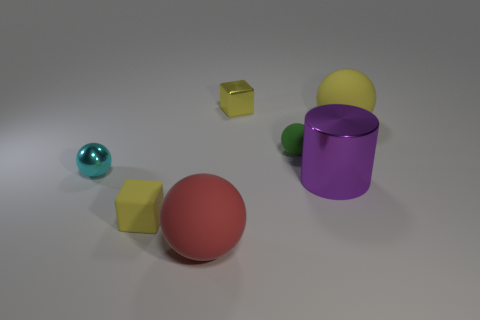Add 1 tiny yellow shiny cubes. How many objects exist? 8 Subtract all cubes. How many objects are left? 5 Subtract 0 purple blocks. How many objects are left? 7 Subtract all large metallic cylinders. Subtract all tiny green things. How many objects are left? 5 Add 5 purple shiny objects. How many purple shiny objects are left? 6 Add 4 spheres. How many spheres exist? 8 